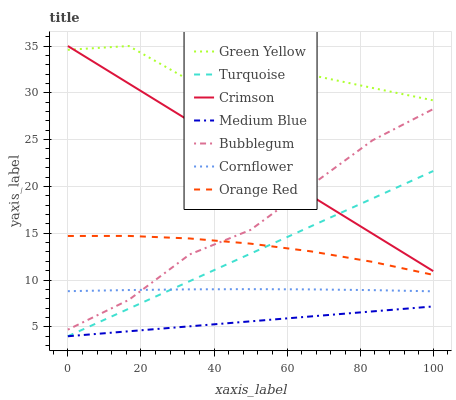Does Medium Blue have the minimum area under the curve?
Answer yes or no. Yes. Does Green Yellow have the maximum area under the curve?
Answer yes or no. Yes. Does Turquoise have the minimum area under the curve?
Answer yes or no. No. Does Turquoise have the maximum area under the curve?
Answer yes or no. No. Is Medium Blue the smoothest?
Answer yes or no. Yes. Is Green Yellow the roughest?
Answer yes or no. Yes. Is Turquoise the smoothest?
Answer yes or no. No. Is Turquoise the roughest?
Answer yes or no. No. Does Turquoise have the lowest value?
Answer yes or no. Yes. Does Bubblegum have the lowest value?
Answer yes or no. No. Does Green Yellow have the highest value?
Answer yes or no. Yes. Does Turquoise have the highest value?
Answer yes or no. No. Is Medium Blue less than Crimson?
Answer yes or no. Yes. Is Green Yellow greater than Medium Blue?
Answer yes or no. Yes. Does Cornflower intersect Bubblegum?
Answer yes or no. Yes. Is Cornflower less than Bubblegum?
Answer yes or no. No. Is Cornflower greater than Bubblegum?
Answer yes or no. No. Does Medium Blue intersect Crimson?
Answer yes or no. No. 